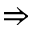Convert formula to latex. <formula><loc_0><loc_0><loc_500><loc_500>\Rightarrow</formula> 